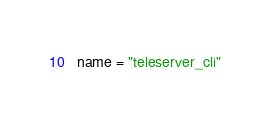Convert code to text. <code><loc_0><loc_0><loc_500><loc_500><_Python_>name = "teleserver_cli"
</code> 